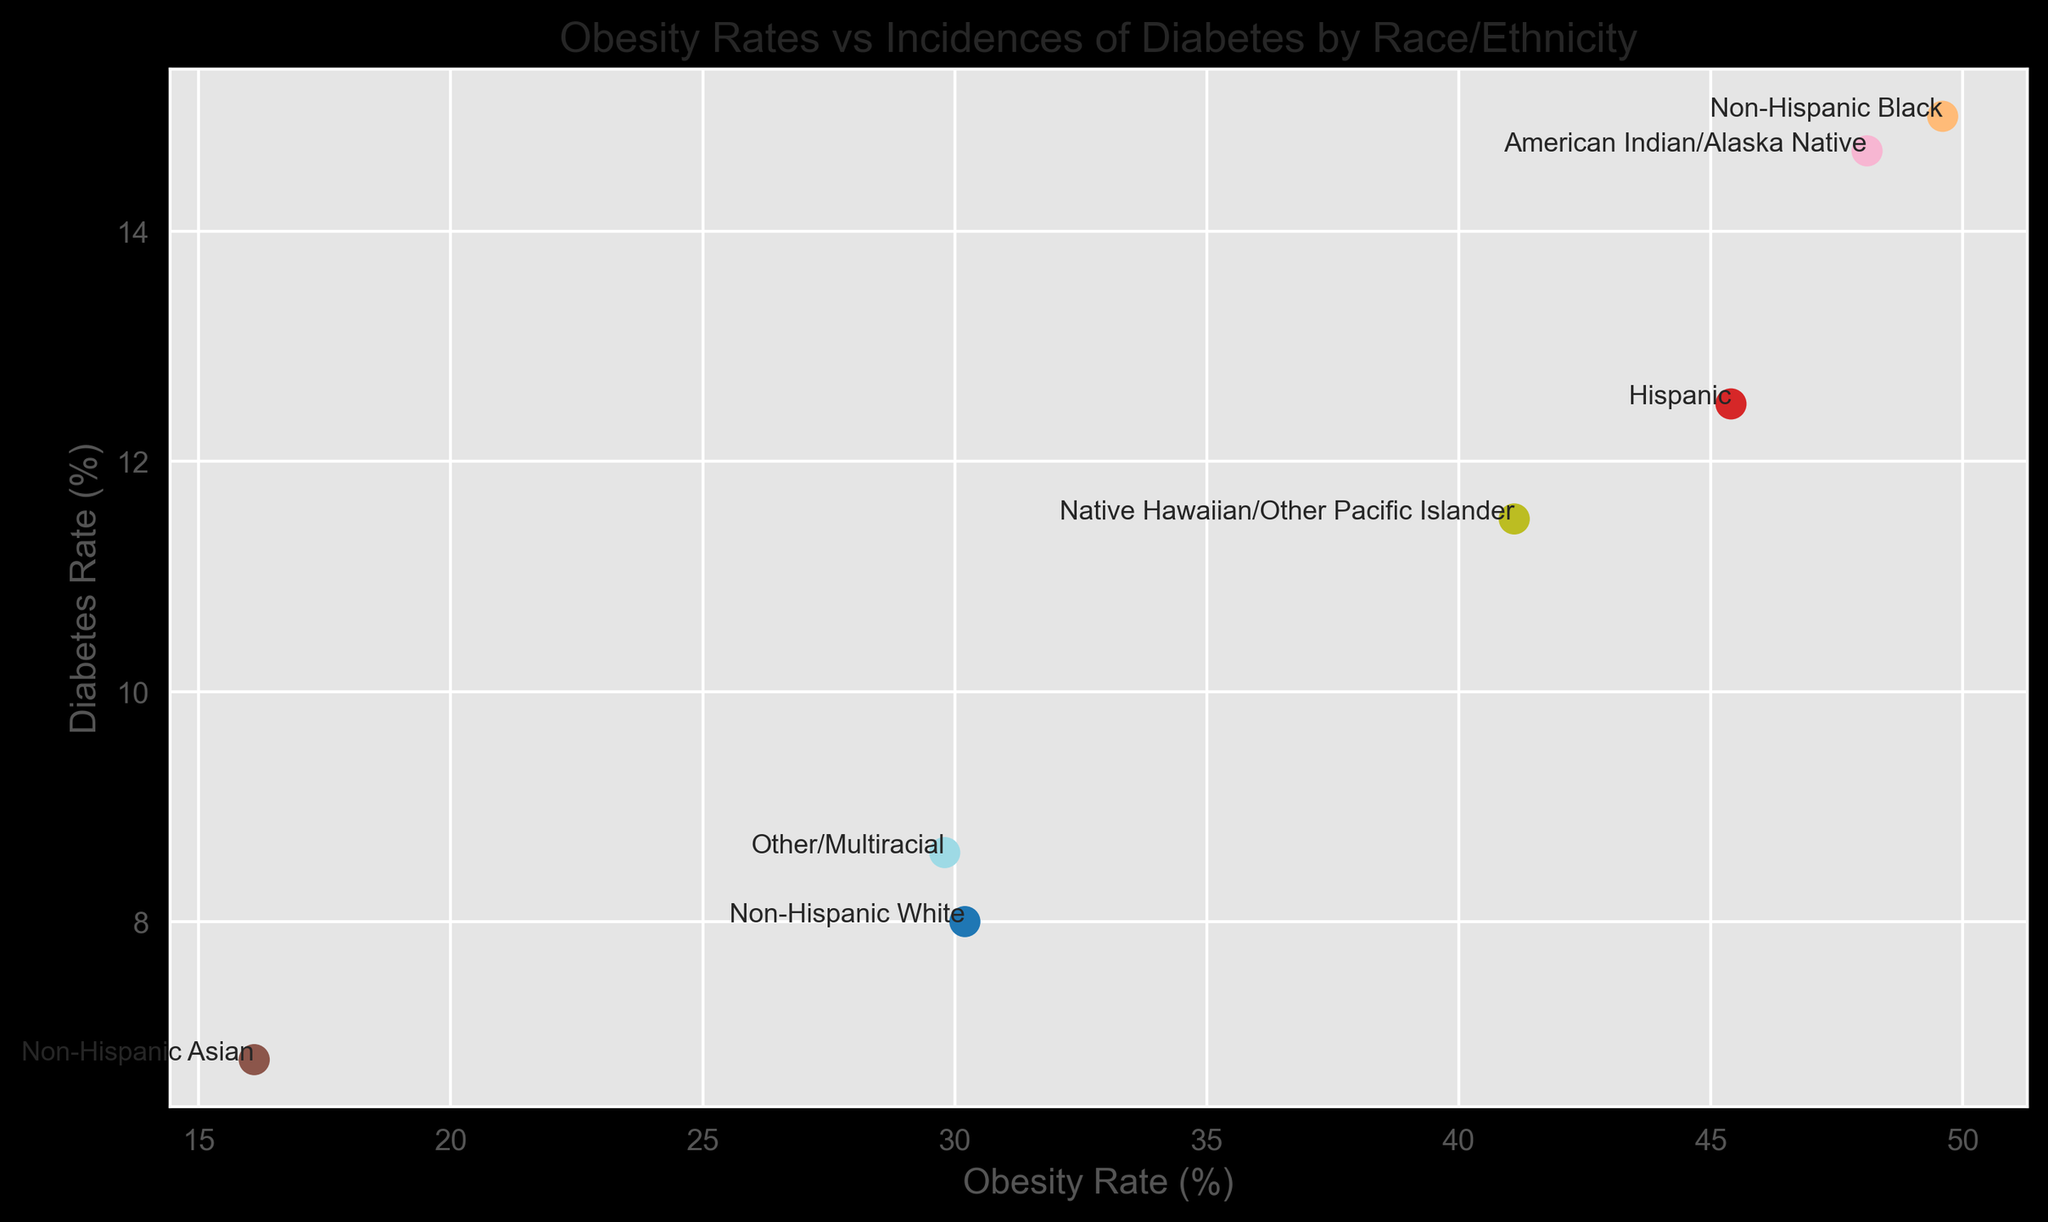What is the relationship between the obesity rate and diabetes rate for Non-Hispanic Black individuals? Non-Hispanic Black individuals have an obesity rate of 49.6% and a diabetes rate of 15.0%. The data point for this group is located towards the upper right of the scatter plot, indicating a high obesity rate correlates with a high diabetes rate for this group.
Answer: High obesity rate correlates with a high diabetes rate Which racial/ethnic group has the lowest obesity rate, and what is their corresponding diabetes rate? The Non-Hispanic Asian group has the lowest obesity rate at 16.1%. Their corresponding diabetes rate is 6.8%, as indicated by the data point located at the lower left of the scatter plot.
Answer: Non-Hispanic Asian: 16.1% obesity rate, 6.8% diabetes rate Compare the diabetes rates of Native Hawaiian/Other Pacific Islander and Hispanic groups. Which group has a higher diabetes rate? The Native Hawaiian/Other Pacific Islander group has a diabetes rate of 11.5%, while the Hispanic group has a higher diabetes rate of 12.5%.
Answer: Hispanic group has a higher diabetes rate Which group has an obesity rate closest to 30%, and what is their diabetes rate? The Non-Hispanic White group has an obesity rate of 30.2%, which is closest to 30%. Their corresponding diabetes rate is 8.0%.
Answer: Non-Hispanic White: 30.2% obesity rate, 8.0% diabetes rate What is the sum of the obesity rates for Non-Hispanic Black and American Indian/Alaska Native groups? Non-Hispanic Black individuals have an obesity rate of 49.6%, and American Indian/Alaska Native individuals have an obesity rate of 48.1%. Summing these rates gives 49.6 + 48.1 = 97.7.
Answer: 97.7% How does the obesity rate of the Other/Multiracial group compare to that of the Non-Hispanic White group? The Non-Hispanic White group has an obesity rate of 30.2% while the Other/Multiracial group has an obesity rate of 29.8%. By comparison, the Other/Multiracial group's obesity rate is slightly lower.
Answer: Other/Multiracial is slightly lower Which two groups have the highest diabetes rates, and what are these rates? The Non-Hispanic Black group has a diabetes rate of 15.0%, and the American Indian/Alaska Native group has a diabetes rate of 14.7%. These two rates are the highest among all groups in the scatter plot.
Answer: Non-Hispanic Black: 15.0%, American Indian/Alaska Native: 14.7% What is the average obesity rate of Non-Hispanic White, Non-Hispanic Asian, and Other/Multiracial groups? The obesity rates are 30.2% for Non-Hispanic White, 16.1% for Non-Hispanic Asian, and 29.8% for Other/Multiracial. The average obesity rate is (30.2 + 16.1 + 29.8) / 3 = 25.37%.
Answer: 25.37% 